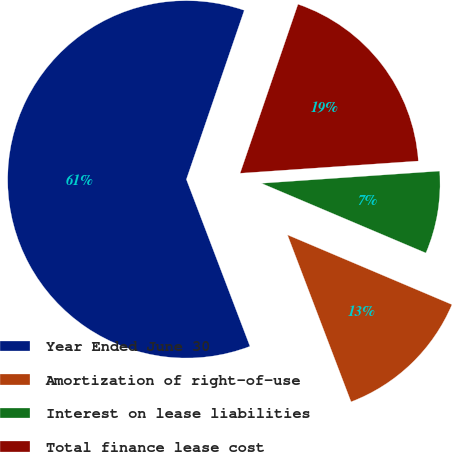Convert chart. <chart><loc_0><loc_0><loc_500><loc_500><pie_chart><fcel>Year Ended June 30<fcel>Amortization of right-of-use<fcel>Interest on lease liabilities<fcel>Total finance lease cost<nl><fcel>61.05%<fcel>12.83%<fcel>7.47%<fcel>18.66%<nl></chart> 